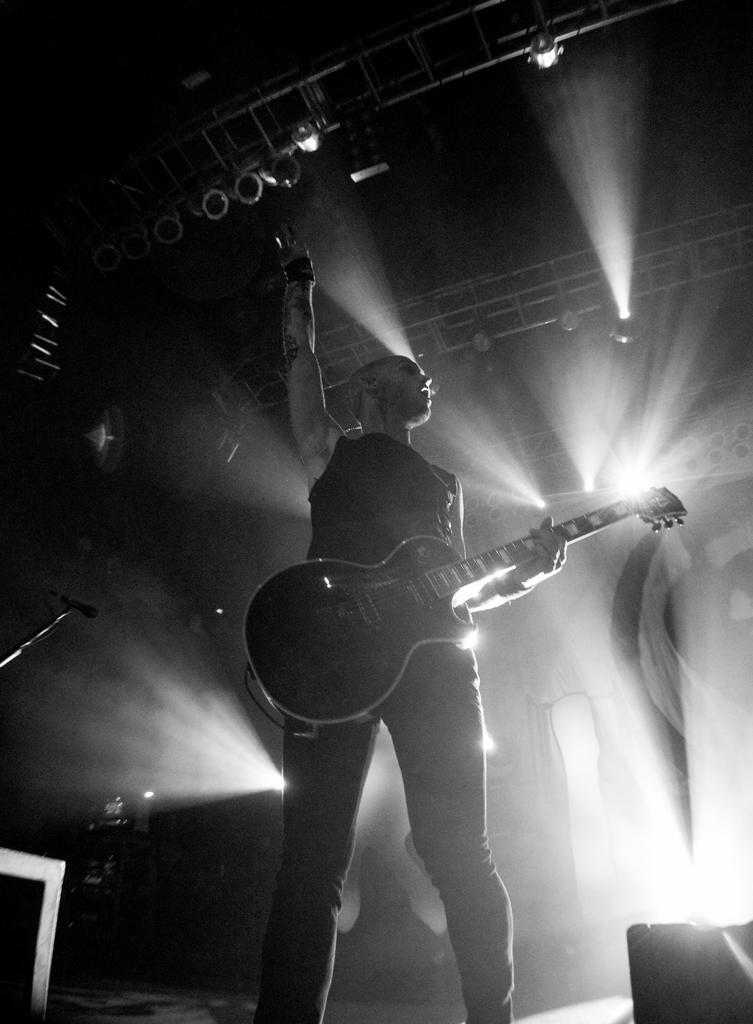Who is the person in the image? There is a man in the image. What is the man doing in the image? The man is playing a guitar. Can you describe any other objects in the image? There is a light on the roof and a microphone on the left side of the image. What type of lock is used to secure the border of the quilt in the image? There is no lock, border, or quilt present in the image. 